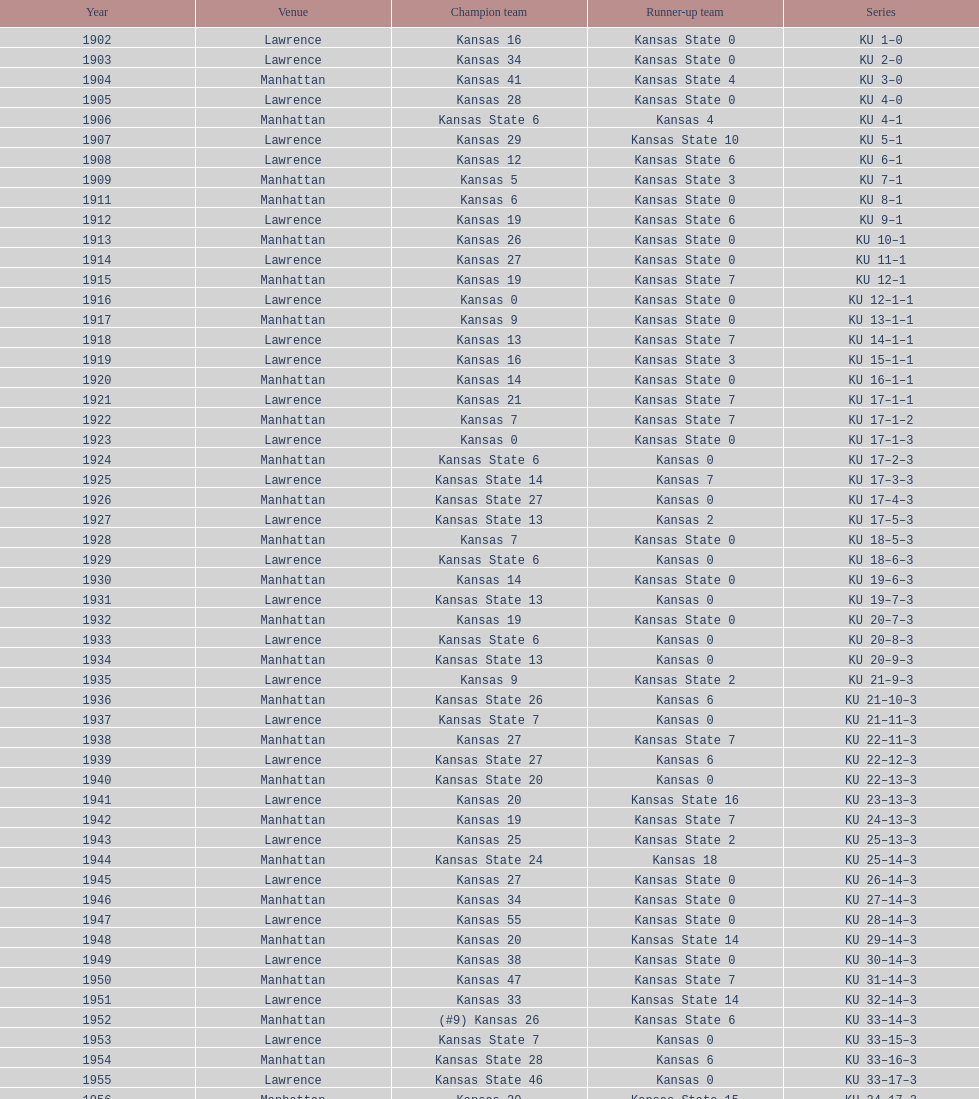Who had the most wins in the 1950's: kansas or kansas state? Kansas. 